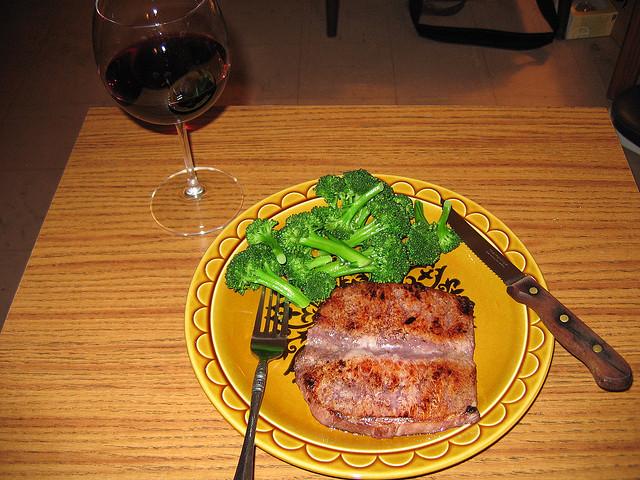Has the diner begun eating?
Write a very short answer. No. What is the green vegetable?
Be succinct. Broccoli. Has this diner chosen the correct color wine for their meal?
Quick response, please. Yes. 